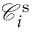<formula> <loc_0><loc_0><loc_500><loc_500>\mathcal { C } _ { i } ^ { s }</formula> 